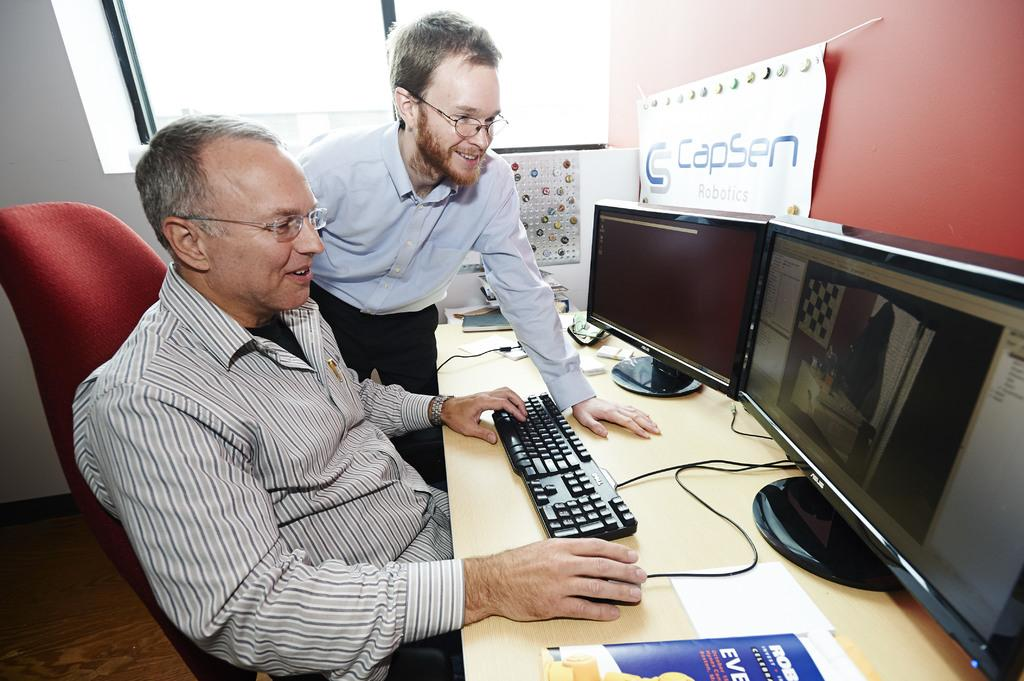<image>
Give a short and clear explanation of the subsequent image. Two men work at a desk under a CapSen sign. 